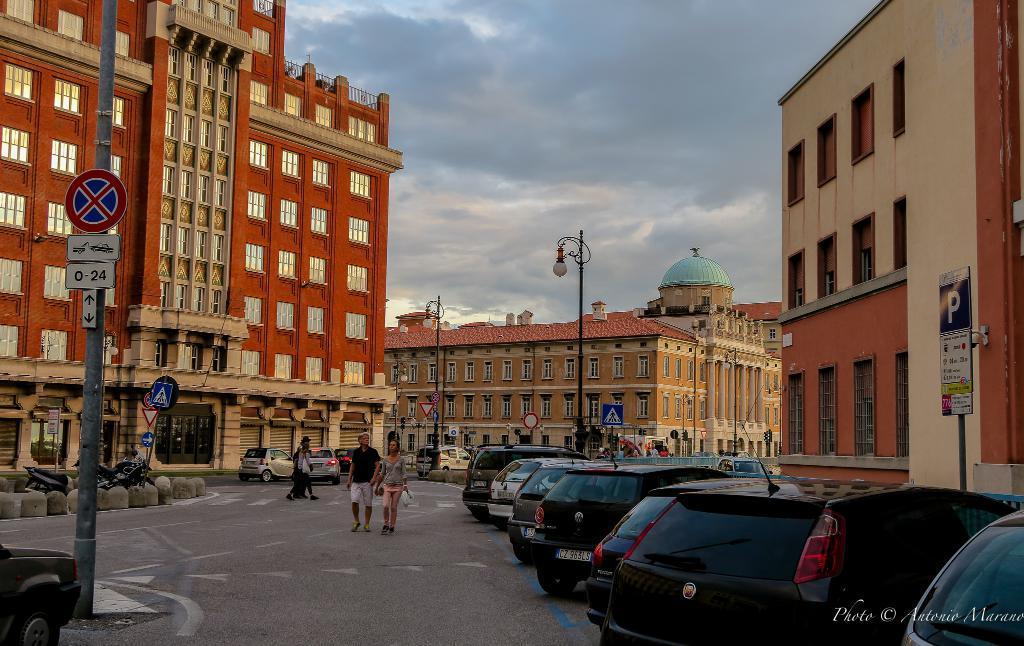How would you summarize this image in a sentence or two? In the middle of the image we can see motor vehicles, persons on the road, street poles, sign boards, street lights and speed limit boards. In the background we can see buildings and sky with clouds. 